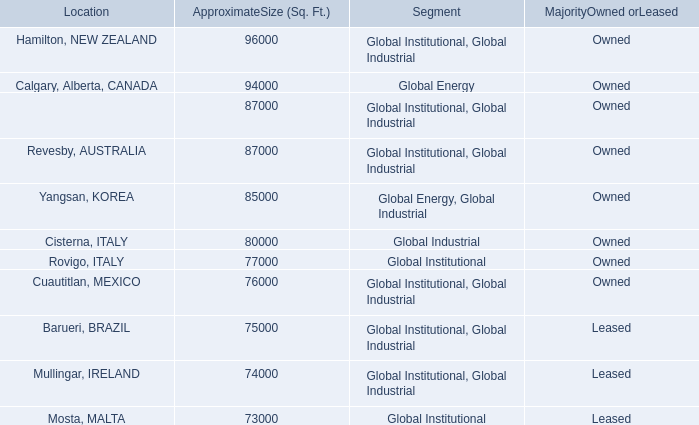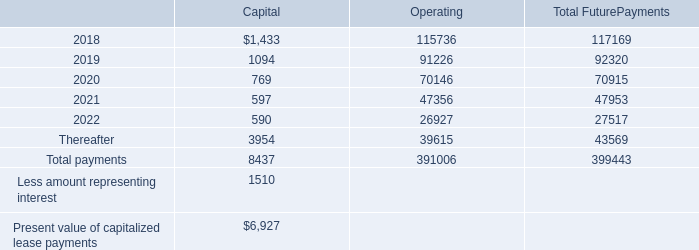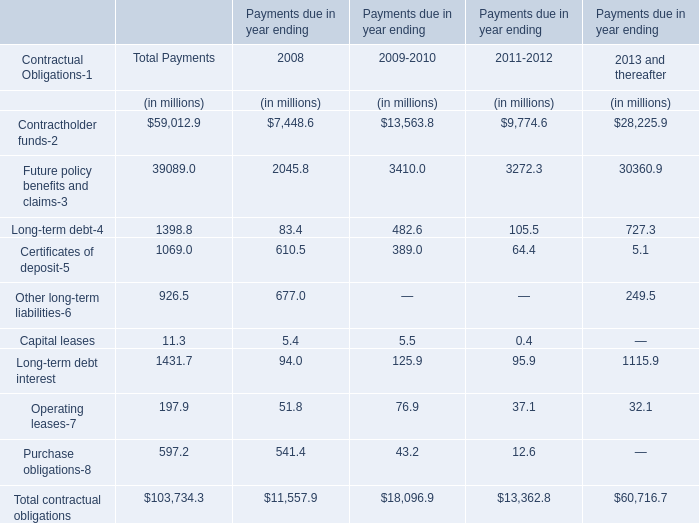What's the 10 % of total elements in 2008? (in million) 
Computations: (11557.9 * 0.1)
Answer: 1155.79. What is the average value of Certificates of deposit-5 in 2008, 2009-2010,2011-2012? (in million) 
Computations: (((610.5 + 389) + 64.4) / 3)
Answer: 354.63333. 